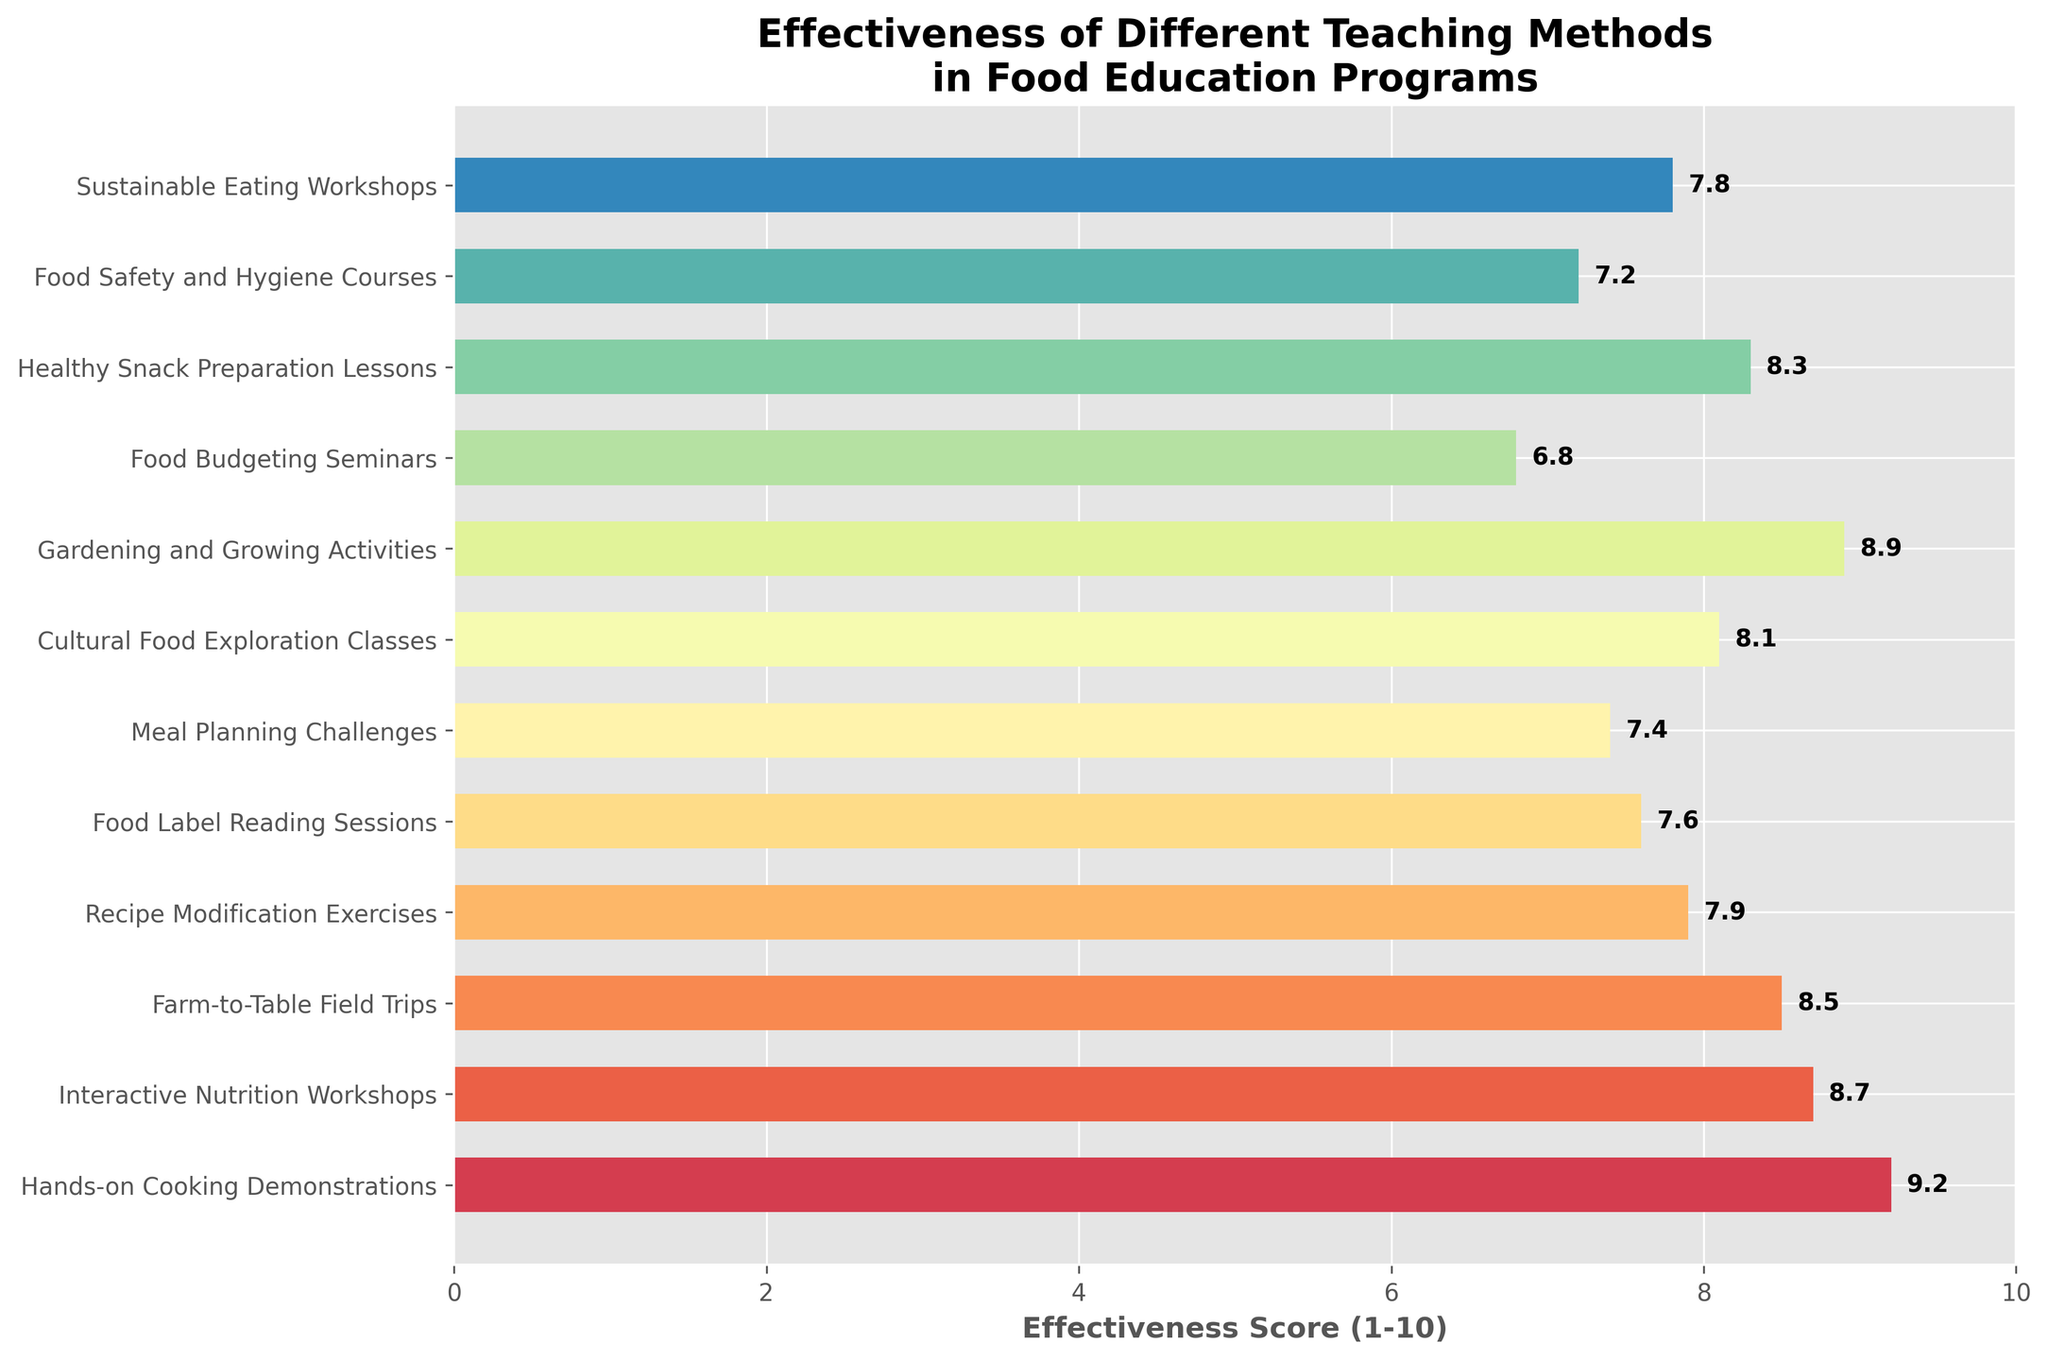Which teaching method is rated the most effective? The highest bar indicates the most effective teaching method. "Hands-on Cooking Demonstrations" has the highest effectiveness score.
Answer: Hands-on Cooking Demonstrations Among "Food Budgeting Seminars" and "Meal Planning Challenges," which one has a higher effectiveness score? Compare the lengths of the bars for both methods. "Meal Planning Challenges" has a longer bar, indicating a higher effectiveness score.
Answer: Meal Planning Challenges What is the difference in the effectiveness scores between the most effective and the least effective teaching methods? The most effective method is "Hands-on Cooking Demonstrations" with a score of 9.2, and the least effective is "Food Budgeting Seminars" with a score of 6.8. Subtract the least from the most: 9.2 - 6.8.
Answer: 2.4 How many teaching methods have an effectiveness score of 8 or higher? Count the bars with scores starting from 8.0 upwards: Hands-on Cooking Demonstrations, Interactive Nutrition Workshops, Farm-to-Table Field Trips, Cultural Food Exploration Classes, Gardening and Growing Activities, Healthy Snack Preparation Lessons.
Answer: 6 Which methods have an effectiveness score within the range of 7.5 to 8.5? Identify bars with scores in the range of 7.5 to 8.5: Interactive Nutrition Workshops, Farm-to-Table Field Trips, Recipe Modification Exercises, Cultural Food Exploration Classes, Healthy Snack Preparation Lessons.
Answer: 5 What’s the average effectiveness score of "Recipe Modification Exercises," "Food Label Reading Sessions," and "Food Safety and Hygiene Courses"? Sum the scores (7.9 + 7.6 + 7.2) and divide by the number of entries: (7.9 + 7.6 + 7.2) / 3.
Answer: 7.6 Is "Sustainable Eating Workshops" more effective than "Food Label Reading Sessions"? Compare their bars' lengths. "Sustainable Eating Workshops" has a score of 7.8, while "Food Label Reading Sessions" has a score of 7.6.
Answer: Yes Which teaching method has the third-highest effectiveness score? Identify the top three scores: 9.2, 8.9, and 8.7. The third one is "Interactive Nutrition Workshops."
Answer: Interactive Nutrition Workshops What is the total effectiveness score of "Gardening and Growing Activities," "Cultural Food Exploration Classes," and "Farm-to-Table Field Trips"? Sum their scores (8.9 + 8.1 + 8.5): 8.9 + 8.1 + 8.5.
Answer: 25.5 Which methods have an effectiveness score lower than 7.5? Identify bars with scores less than 7.5: Food Budgeting Seminars, Meal Planning Challenges, Food Safety and Hygiene Courses.
Answer: 3 